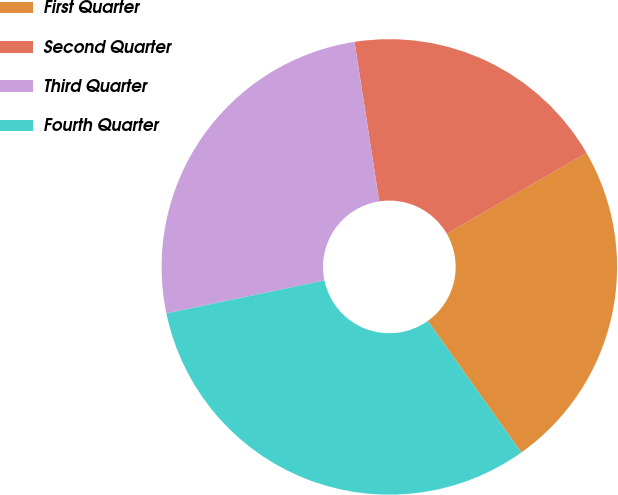<chart> <loc_0><loc_0><loc_500><loc_500><pie_chart><fcel>First Quarter<fcel>Second Quarter<fcel>Third Quarter<fcel>Fourth Quarter<nl><fcel>23.5%<fcel>19.1%<fcel>25.83%<fcel>31.57%<nl></chart> 